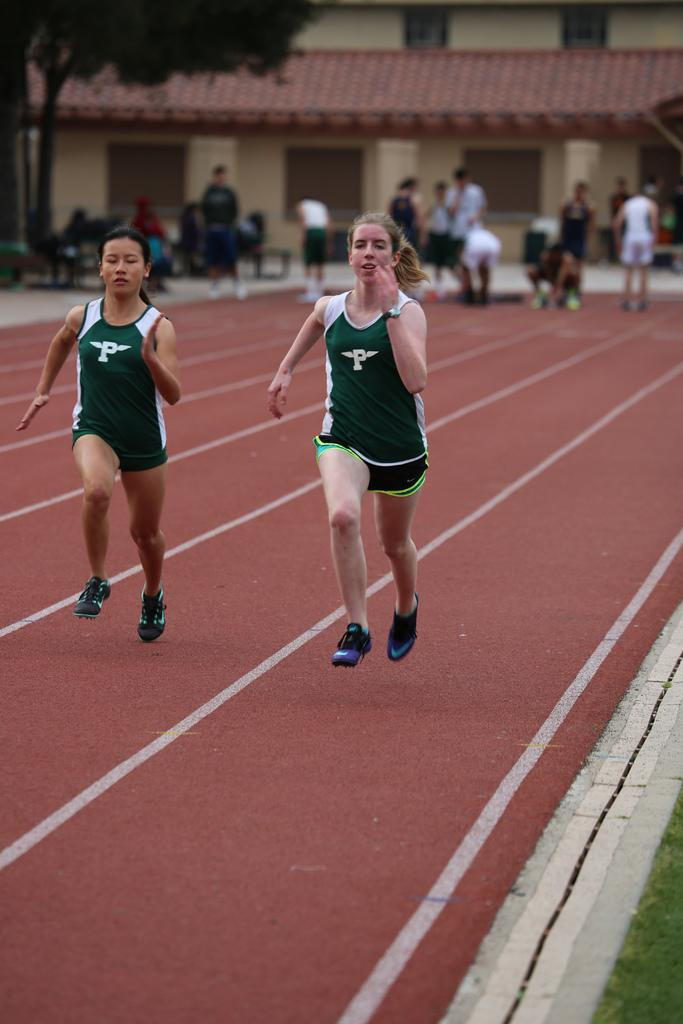How many people are in the image? There is a group of people in the image. What are some of the people doing in the image? Some people are standing, some are seated, and two women are running. What can be seen in the background of the image? There is a house and trees in the background of the image. What type of squirrel can be seen climbing the house in the image? There is no squirrel present in the image; it only features a group of people and a house in the background. What ingredients are used to make the stew that is being served in the image? There is no stew present in the image, so it's not possible to determine the ingredients used. 